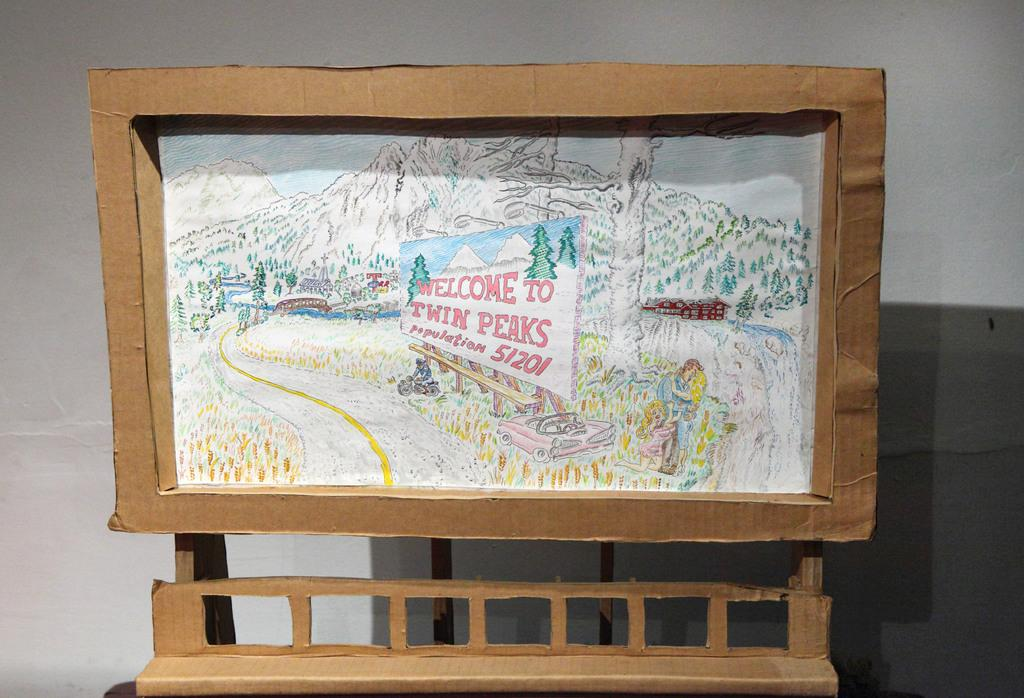<image>
Write a terse but informative summary of the picture. A framed piece of art depicts a sign that says Welcome to Twin Peaks. 